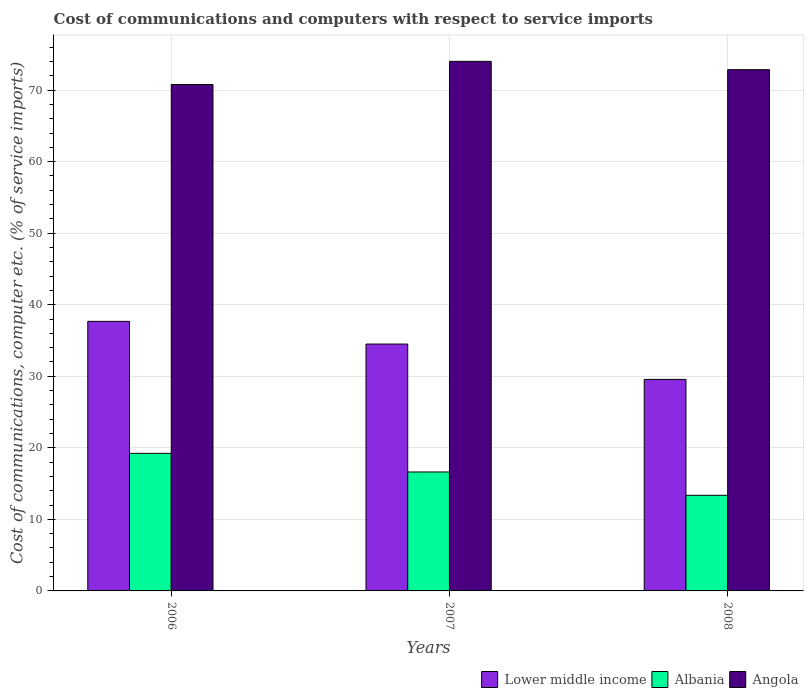How many different coloured bars are there?
Offer a very short reply. 3. How many groups of bars are there?
Offer a terse response. 3. How many bars are there on the 3rd tick from the right?
Your response must be concise. 3. What is the label of the 2nd group of bars from the left?
Offer a terse response. 2007. In how many cases, is the number of bars for a given year not equal to the number of legend labels?
Your answer should be compact. 0. What is the cost of communications and computers in Angola in 2006?
Offer a terse response. 70.78. Across all years, what is the maximum cost of communications and computers in Lower middle income?
Your answer should be very brief. 37.67. Across all years, what is the minimum cost of communications and computers in Albania?
Keep it short and to the point. 13.37. In which year was the cost of communications and computers in Albania minimum?
Keep it short and to the point. 2008. What is the total cost of communications and computers in Lower middle income in the graph?
Offer a terse response. 101.74. What is the difference between the cost of communications and computers in Angola in 2007 and that in 2008?
Your response must be concise. 1.16. What is the difference between the cost of communications and computers in Lower middle income in 2007 and the cost of communications and computers in Albania in 2006?
Your response must be concise. 15.27. What is the average cost of communications and computers in Albania per year?
Make the answer very short. 16.41. In the year 2006, what is the difference between the cost of communications and computers in Albania and cost of communications and computers in Lower middle income?
Give a very brief answer. -18.45. In how many years, is the cost of communications and computers in Angola greater than 16 %?
Make the answer very short. 3. What is the ratio of the cost of communications and computers in Lower middle income in 2006 to that in 2007?
Your answer should be compact. 1.09. Is the cost of communications and computers in Angola in 2006 less than that in 2008?
Your response must be concise. Yes. What is the difference between the highest and the second highest cost of communications and computers in Lower middle income?
Ensure brevity in your answer.  3.17. What is the difference between the highest and the lowest cost of communications and computers in Angola?
Keep it short and to the point. 3.24. In how many years, is the cost of communications and computers in Angola greater than the average cost of communications and computers in Angola taken over all years?
Make the answer very short. 2. What does the 3rd bar from the left in 2008 represents?
Offer a terse response. Angola. What does the 2nd bar from the right in 2006 represents?
Give a very brief answer. Albania. How many bars are there?
Offer a very short reply. 9. What is the difference between two consecutive major ticks on the Y-axis?
Offer a very short reply. 10. Does the graph contain any zero values?
Offer a very short reply. No. Where does the legend appear in the graph?
Ensure brevity in your answer.  Bottom right. How many legend labels are there?
Offer a very short reply. 3. What is the title of the graph?
Ensure brevity in your answer.  Cost of communications and computers with respect to service imports. What is the label or title of the Y-axis?
Your answer should be very brief. Cost of communications, computer etc. (% of service imports). What is the Cost of communications, computer etc. (% of service imports) of Lower middle income in 2006?
Your response must be concise. 37.67. What is the Cost of communications, computer etc. (% of service imports) in Albania in 2006?
Your response must be concise. 19.23. What is the Cost of communications, computer etc. (% of service imports) in Angola in 2006?
Your response must be concise. 70.78. What is the Cost of communications, computer etc. (% of service imports) in Lower middle income in 2007?
Keep it short and to the point. 34.5. What is the Cost of communications, computer etc. (% of service imports) in Albania in 2007?
Ensure brevity in your answer.  16.62. What is the Cost of communications, computer etc. (% of service imports) of Angola in 2007?
Provide a succinct answer. 74.02. What is the Cost of communications, computer etc. (% of service imports) in Lower middle income in 2008?
Provide a succinct answer. 29.56. What is the Cost of communications, computer etc. (% of service imports) in Albania in 2008?
Provide a succinct answer. 13.37. What is the Cost of communications, computer etc. (% of service imports) of Angola in 2008?
Offer a terse response. 72.85. Across all years, what is the maximum Cost of communications, computer etc. (% of service imports) in Lower middle income?
Provide a succinct answer. 37.67. Across all years, what is the maximum Cost of communications, computer etc. (% of service imports) of Albania?
Provide a succinct answer. 19.23. Across all years, what is the maximum Cost of communications, computer etc. (% of service imports) in Angola?
Offer a very short reply. 74.02. Across all years, what is the minimum Cost of communications, computer etc. (% of service imports) in Lower middle income?
Make the answer very short. 29.56. Across all years, what is the minimum Cost of communications, computer etc. (% of service imports) in Albania?
Provide a succinct answer. 13.37. Across all years, what is the minimum Cost of communications, computer etc. (% of service imports) of Angola?
Give a very brief answer. 70.78. What is the total Cost of communications, computer etc. (% of service imports) of Lower middle income in the graph?
Keep it short and to the point. 101.74. What is the total Cost of communications, computer etc. (% of service imports) in Albania in the graph?
Offer a very short reply. 49.22. What is the total Cost of communications, computer etc. (% of service imports) in Angola in the graph?
Offer a very short reply. 217.65. What is the difference between the Cost of communications, computer etc. (% of service imports) of Lower middle income in 2006 and that in 2007?
Offer a very short reply. 3.17. What is the difference between the Cost of communications, computer etc. (% of service imports) in Albania in 2006 and that in 2007?
Offer a very short reply. 2.6. What is the difference between the Cost of communications, computer etc. (% of service imports) of Angola in 2006 and that in 2007?
Your answer should be very brief. -3.24. What is the difference between the Cost of communications, computer etc. (% of service imports) in Lower middle income in 2006 and that in 2008?
Your answer should be compact. 8.11. What is the difference between the Cost of communications, computer etc. (% of service imports) of Albania in 2006 and that in 2008?
Make the answer very short. 5.86. What is the difference between the Cost of communications, computer etc. (% of service imports) in Angola in 2006 and that in 2008?
Your response must be concise. -2.07. What is the difference between the Cost of communications, computer etc. (% of service imports) of Lower middle income in 2007 and that in 2008?
Ensure brevity in your answer.  4.94. What is the difference between the Cost of communications, computer etc. (% of service imports) of Albania in 2007 and that in 2008?
Your answer should be compact. 3.26. What is the difference between the Cost of communications, computer etc. (% of service imports) of Angola in 2007 and that in 2008?
Ensure brevity in your answer.  1.16. What is the difference between the Cost of communications, computer etc. (% of service imports) of Lower middle income in 2006 and the Cost of communications, computer etc. (% of service imports) of Albania in 2007?
Provide a short and direct response. 21.05. What is the difference between the Cost of communications, computer etc. (% of service imports) in Lower middle income in 2006 and the Cost of communications, computer etc. (% of service imports) in Angola in 2007?
Keep it short and to the point. -36.34. What is the difference between the Cost of communications, computer etc. (% of service imports) of Albania in 2006 and the Cost of communications, computer etc. (% of service imports) of Angola in 2007?
Your answer should be very brief. -54.79. What is the difference between the Cost of communications, computer etc. (% of service imports) in Lower middle income in 2006 and the Cost of communications, computer etc. (% of service imports) in Albania in 2008?
Your answer should be compact. 24.31. What is the difference between the Cost of communications, computer etc. (% of service imports) of Lower middle income in 2006 and the Cost of communications, computer etc. (% of service imports) of Angola in 2008?
Give a very brief answer. -35.18. What is the difference between the Cost of communications, computer etc. (% of service imports) of Albania in 2006 and the Cost of communications, computer etc. (% of service imports) of Angola in 2008?
Provide a short and direct response. -53.62. What is the difference between the Cost of communications, computer etc. (% of service imports) in Lower middle income in 2007 and the Cost of communications, computer etc. (% of service imports) in Albania in 2008?
Provide a short and direct response. 21.14. What is the difference between the Cost of communications, computer etc. (% of service imports) of Lower middle income in 2007 and the Cost of communications, computer etc. (% of service imports) of Angola in 2008?
Offer a terse response. -38.35. What is the difference between the Cost of communications, computer etc. (% of service imports) in Albania in 2007 and the Cost of communications, computer etc. (% of service imports) in Angola in 2008?
Provide a succinct answer. -56.23. What is the average Cost of communications, computer etc. (% of service imports) in Lower middle income per year?
Your response must be concise. 33.91. What is the average Cost of communications, computer etc. (% of service imports) in Albania per year?
Ensure brevity in your answer.  16.41. What is the average Cost of communications, computer etc. (% of service imports) of Angola per year?
Your answer should be compact. 72.55. In the year 2006, what is the difference between the Cost of communications, computer etc. (% of service imports) of Lower middle income and Cost of communications, computer etc. (% of service imports) of Albania?
Your answer should be compact. 18.45. In the year 2006, what is the difference between the Cost of communications, computer etc. (% of service imports) in Lower middle income and Cost of communications, computer etc. (% of service imports) in Angola?
Give a very brief answer. -33.1. In the year 2006, what is the difference between the Cost of communications, computer etc. (% of service imports) of Albania and Cost of communications, computer etc. (% of service imports) of Angola?
Keep it short and to the point. -51.55. In the year 2007, what is the difference between the Cost of communications, computer etc. (% of service imports) in Lower middle income and Cost of communications, computer etc. (% of service imports) in Albania?
Keep it short and to the point. 17.88. In the year 2007, what is the difference between the Cost of communications, computer etc. (% of service imports) in Lower middle income and Cost of communications, computer etc. (% of service imports) in Angola?
Make the answer very short. -39.51. In the year 2007, what is the difference between the Cost of communications, computer etc. (% of service imports) in Albania and Cost of communications, computer etc. (% of service imports) in Angola?
Your response must be concise. -57.39. In the year 2008, what is the difference between the Cost of communications, computer etc. (% of service imports) of Lower middle income and Cost of communications, computer etc. (% of service imports) of Albania?
Your answer should be compact. 16.2. In the year 2008, what is the difference between the Cost of communications, computer etc. (% of service imports) of Lower middle income and Cost of communications, computer etc. (% of service imports) of Angola?
Make the answer very short. -43.29. In the year 2008, what is the difference between the Cost of communications, computer etc. (% of service imports) of Albania and Cost of communications, computer etc. (% of service imports) of Angola?
Ensure brevity in your answer.  -59.49. What is the ratio of the Cost of communications, computer etc. (% of service imports) in Lower middle income in 2006 to that in 2007?
Offer a terse response. 1.09. What is the ratio of the Cost of communications, computer etc. (% of service imports) in Albania in 2006 to that in 2007?
Make the answer very short. 1.16. What is the ratio of the Cost of communications, computer etc. (% of service imports) of Angola in 2006 to that in 2007?
Your answer should be compact. 0.96. What is the ratio of the Cost of communications, computer etc. (% of service imports) of Lower middle income in 2006 to that in 2008?
Give a very brief answer. 1.27. What is the ratio of the Cost of communications, computer etc. (% of service imports) in Albania in 2006 to that in 2008?
Your answer should be very brief. 1.44. What is the ratio of the Cost of communications, computer etc. (% of service imports) of Angola in 2006 to that in 2008?
Your response must be concise. 0.97. What is the ratio of the Cost of communications, computer etc. (% of service imports) in Lower middle income in 2007 to that in 2008?
Make the answer very short. 1.17. What is the ratio of the Cost of communications, computer etc. (% of service imports) in Albania in 2007 to that in 2008?
Your response must be concise. 1.24. What is the ratio of the Cost of communications, computer etc. (% of service imports) of Angola in 2007 to that in 2008?
Provide a short and direct response. 1.02. What is the difference between the highest and the second highest Cost of communications, computer etc. (% of service imports) of Lower middle income?
Your answer should be compact. 3.17. What is the difference between the highest and the second highest Cost of communications, computer etc. (% of service imports) in Albania?
Your answer should be compact. 2.6. What is the difference between the highest and the second highest Cost of communications, computer etc. (% of service imports) in Angola?
Your answer should be compact. 1.16. What is the difference between the highest and the lowest Cost of communications, computer etc. (% of service imports) of Lower middle income?
Provide a succinct answer. 8.11. What is the difference between the highest and the lowest Cost of communications, computer etc. (% of service imports) of Albania?
Your answer should be very brief. 5.86. What is the difference between the highest and the lowest Cost of communications, computer etc. (% of service imports) of Angola?
Keep it short and to the point. 3.24. 